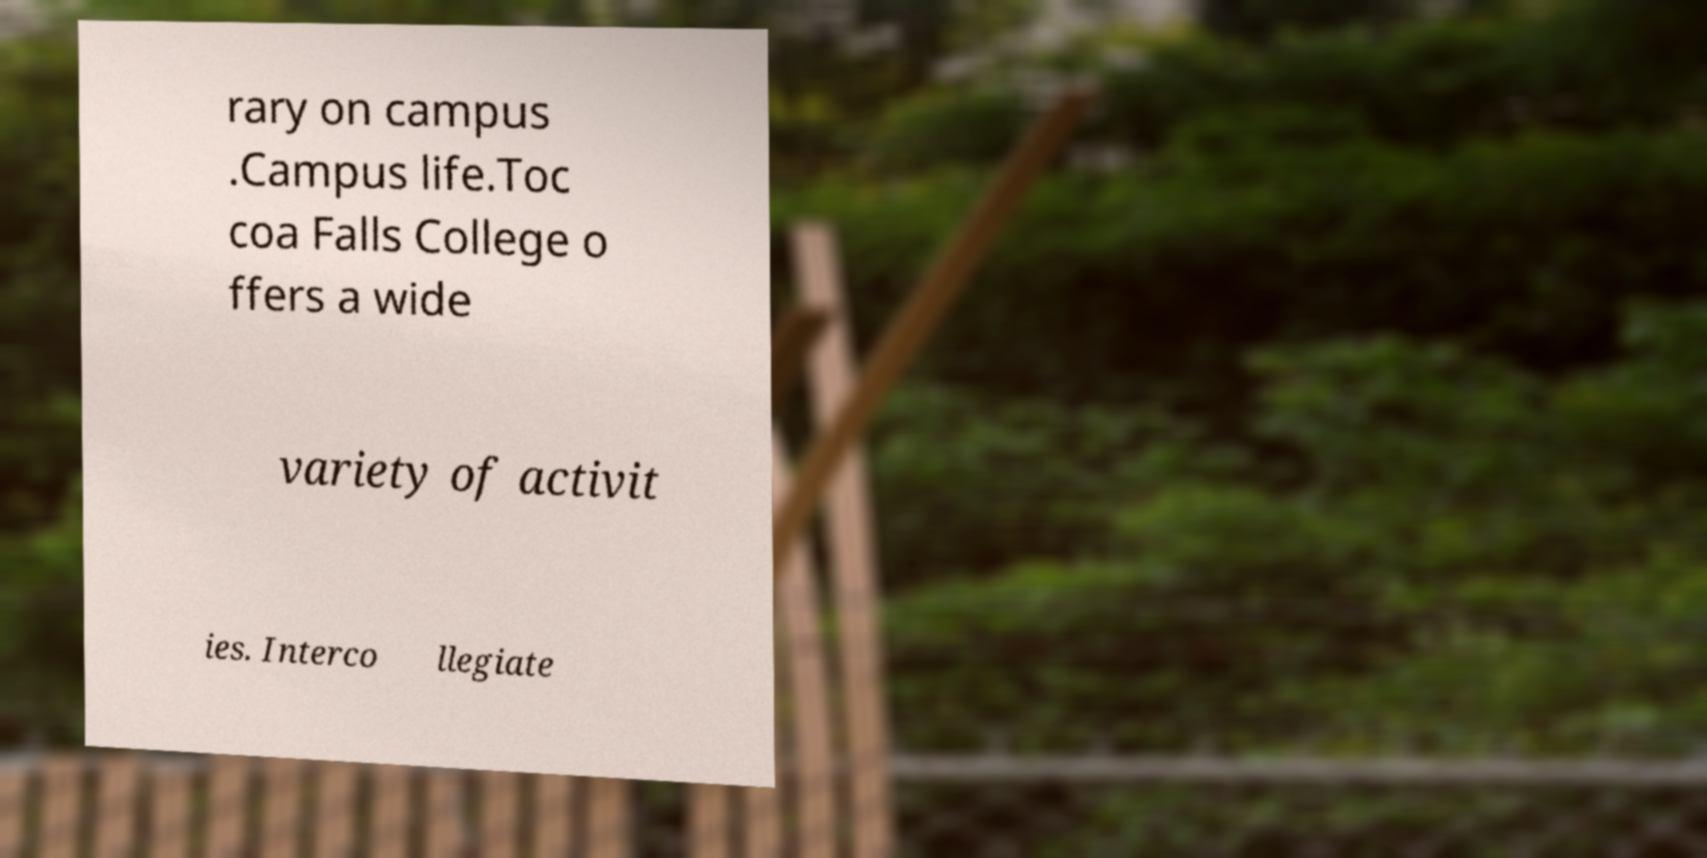Can you accurately transcribe the text from the provided image for me? rary on campus .Campus life.Toc coa Falls College o ffers a wide variety of activit ies. Interco llegiate 